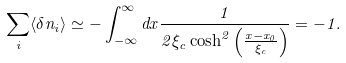<formula> <loc_0><loc_0><loc_500><loc_500>\sum _ { i } \langle \delta n _ { i } \rangle \simeq - \int ^ { \infty } _ { - \infty } d x \frac { 1 } { 2 \xi _ { c } \cosh ^ { 2 } \left ( \frac { x - x _ { 0 } } { \xi _ { c } } \right ) } = - 1 .</formula> 